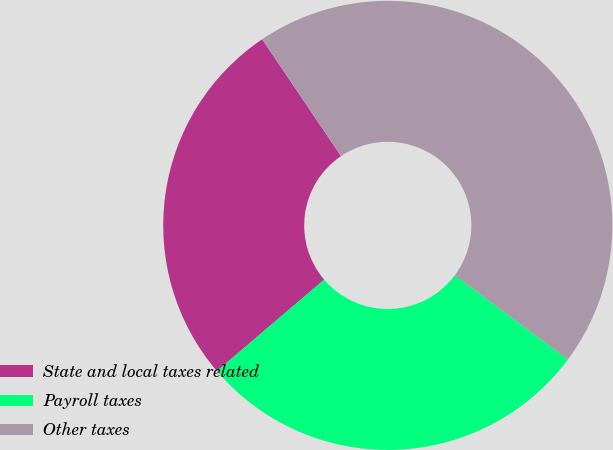Convert chart to OTSL. <chart><loc_0><loc_0><loc_500><loc_500><pie_chart><fcel>State and local taxes related<fcel>Payroll taxes<fcel>Other taxes<nl><fcel>26.79%<fcel>28.57%<fcel>44.64%<nl></chart> 